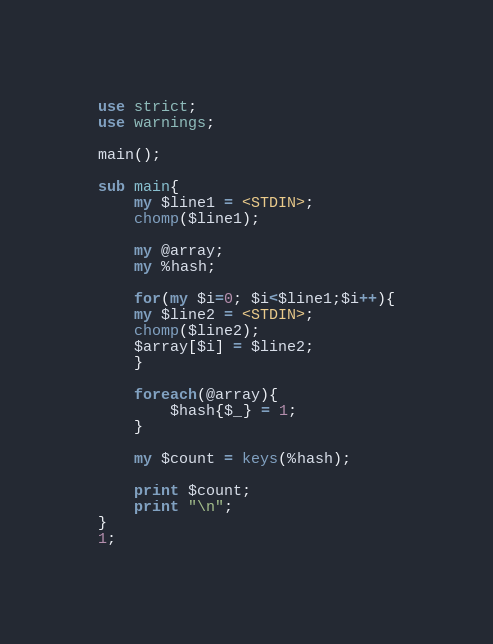<code> <loc_0><loc_0><loc_500><loc_500><_Perl_>use strict;
use warnings;

main();

sub main{
	my $line1 = <STDIN>;
	chomp($line1);

	my @array;
	my %hash;

	for(my $i=0; $i<$line1;$i++){
	my $line2 = <STDIN>;
	chomp($line2);
	$array[$i] = $line2;
	}
	
	foreach(@array){
		$hash{$_} = 1;
	}
	
	my $count = keys(%hash);
	
	print $count;
	print "\n";
}
1;</code> 